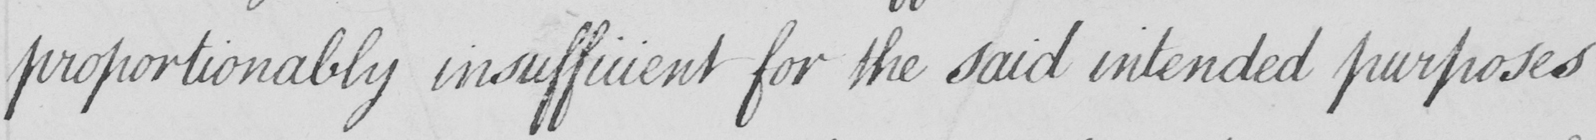What is written in this line of handwriting? proportionally insufficient for the said intended purposes 